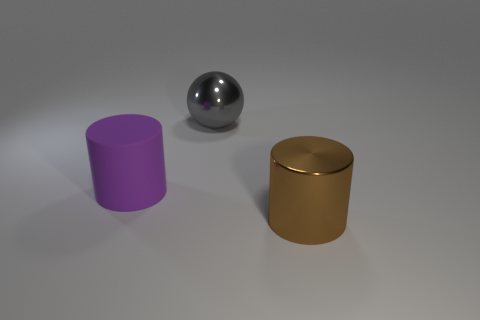Are there any other things that have the same material as the big purple object?
Offer a terse response. No. Are there any other things that are the same shape as the gray object?
Offer a very short reply. No. What number of big objects are to the right of the big gray metal ball and on the left side of the large metal sphere?
Ensure brevity in your answer.  0. There is a purple matte object that is the same size as the metal cylinder; what is its shape?
Offer a very short reply. Cylinder. Are there any cylinders in front of the metal object to the left of the large metallic thing in front of the gray thing?
Your answer should be very brief. Yes. There is a large shiny cylinder; is it the same color as the cylinder to the left of the big gray sphere?
Offer a terse response. No. What number of other metallic cylinders have the same color as the shiny cylinder?
Your answer should be very brief. 0. What is the size of the cylinder on the left side of the thing that is to the right of the gray shiny sphere?
Offer a terse response. Large. How many objects are either shiny things that are behind the large purple object or tiny brown metal blocks?
Provide a succinct answer. 1. Are there any other purple rubber cylinders of the same size as the purple cylinder?
Keep it short and to the point. No. 